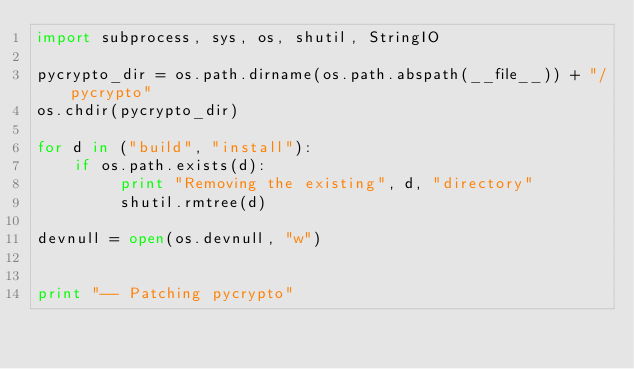<code> <loc_0><loc_0><loc_500><loc_500><_Python_>import subprocess, sys, os, shutil, StringIO

pycrypto_dir = os.path.dirname(os.path.abspath(__file__)) + "/pycrypto"
os.chdir(pycrypto_dir)

for d in ("build", "install"):
    if os.path.exists(d):
         print "Removing the existing", d, "directory"
         shutil.rmtree(d)

devnull = open(os.devnull, "w")


print "-- Patching pycrypto"</code> 